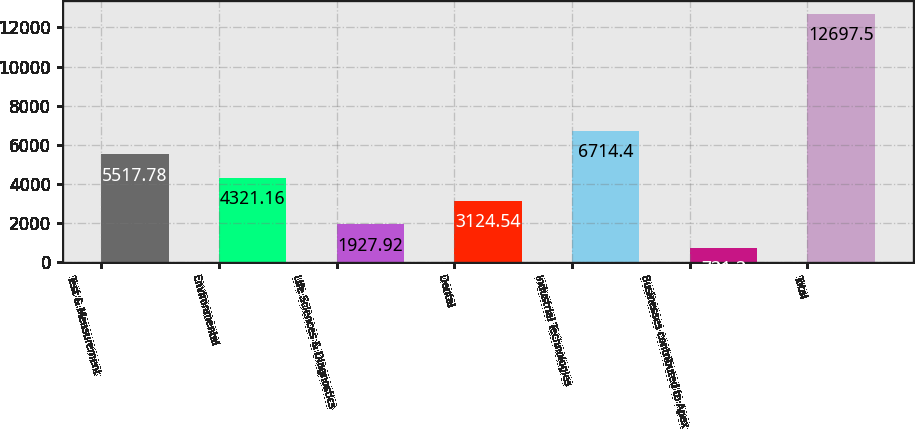Convert chart. <chart><loc_0><loc_0><loc_500><loc_500><bar_chart><fcel>Test & Measurement<fcel>Environmental<fcel>Life Sciences & Diagnostics<fcel>Dental<fcel>Industrial Technologies<fcel>Businesses contributed to Apex<fcel>Total<nl><fcel>5517.78<fcel>4321.16<fcel>1927.92<fcel>3124.54<fcel>6714.4<fcel>731.3<fcel>12697.5<nl></chart> 